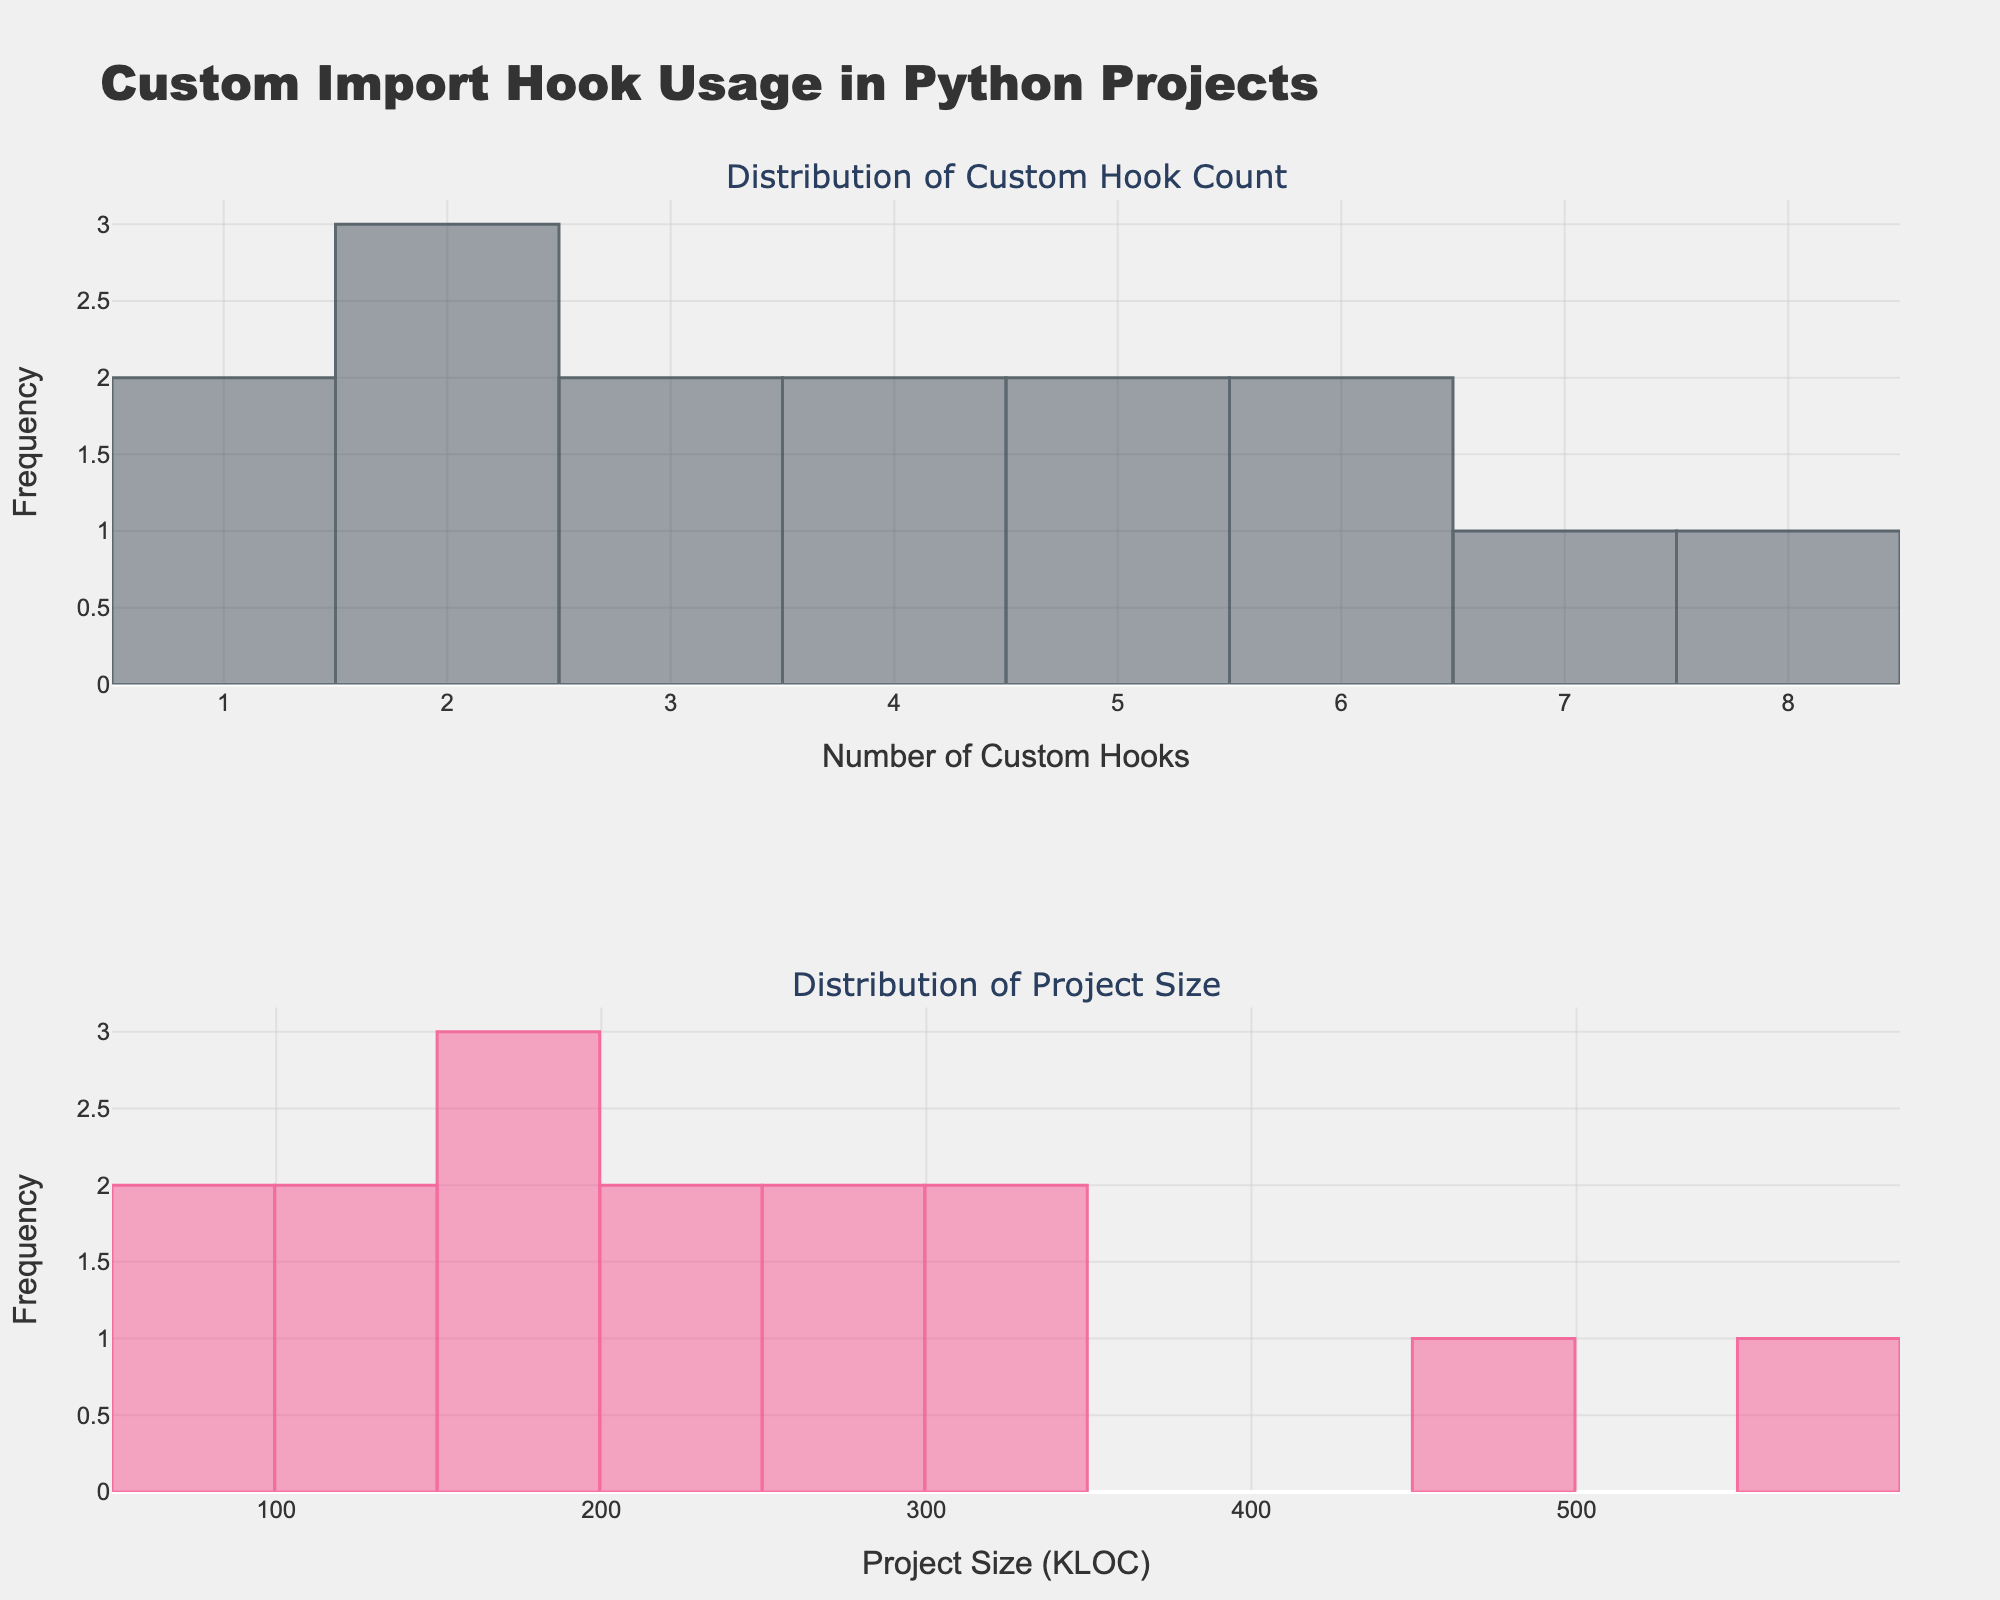what is the title of the figure? The title of the figure is usually found at the top of the plot.
Answer: Custom Import Hook Usage in Python Projects What does the top histogram represent? The x-axis and the title of the histogram indicate what it represents. The top histogram is labeled as "Number of Custom Hooks," showing the frequency of different counts of custom hooks.
Answer: Distribution of Custom Hook Count What is the color of the bars in the bottom histogram? The colors are typically distinguishable by visual inspection. The bottom histogram bars are colored in pinkish shades.
Answer: Pinkish shades How many bins are used for the histogram of project sizes? The number of bins can be inferred from the code or by counting the distinct bars in the histogram. The code specifies 15 bins for the project size distribution.
Answer: 15 Which custom hook count appears most frequently? We look at the top histogram and identify the bar with the highest height.
Answer: 2 and 4 Which project size (KLOC) has the highest frequency? We look at the bottom histogram and identify the bar with the highest height. The project size ranges that appear most frequently are the bins around 150-200 KLOC.
Answer: 150-200 KLOC How many projects have a custom hook count between 3 and 5? To find this, count the frequency of the bins from 3 to 5 in the top histogram. The relevant bins are those with custom hook counts of 3, 4, and 5.
Answer: 12 Which has a higher number of bins, custom hook count or project size histogram? Count the bins in both histograms. The top histogram has 10 bins and the bottom has 15 bins, so the project size histogram has more bins.
Answer: Project size histogram Do projects with a larger KLOC range correlate with more custom hooks? This requires comparing the two histograms. One would look for whether bigger projects (higher KLOC) tend to align with higher custom hook counts. There appears to be no strong direct correlation visible in the plot.
Answer: No strong correlation What is the range of project sizes (KLOC) shown in the bottom histogram? Look at the x-axis of the bottom histogram to identify the range of project sizes. The range goes from about 0 to 600 KLOC.
Answer: 0 to 600 KLOC 